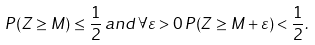Convert formula to latex. <formula><loc_0><loc_0><loc_500><loc_500>P ( Z \geq M ) \leq \frac { 1 } { 2 } \, a n d \, \forall \varepsilon > 0 \, P ( Z \geq M + \varepsilon ) < \frac { 1 } { 2 } .</formula> 